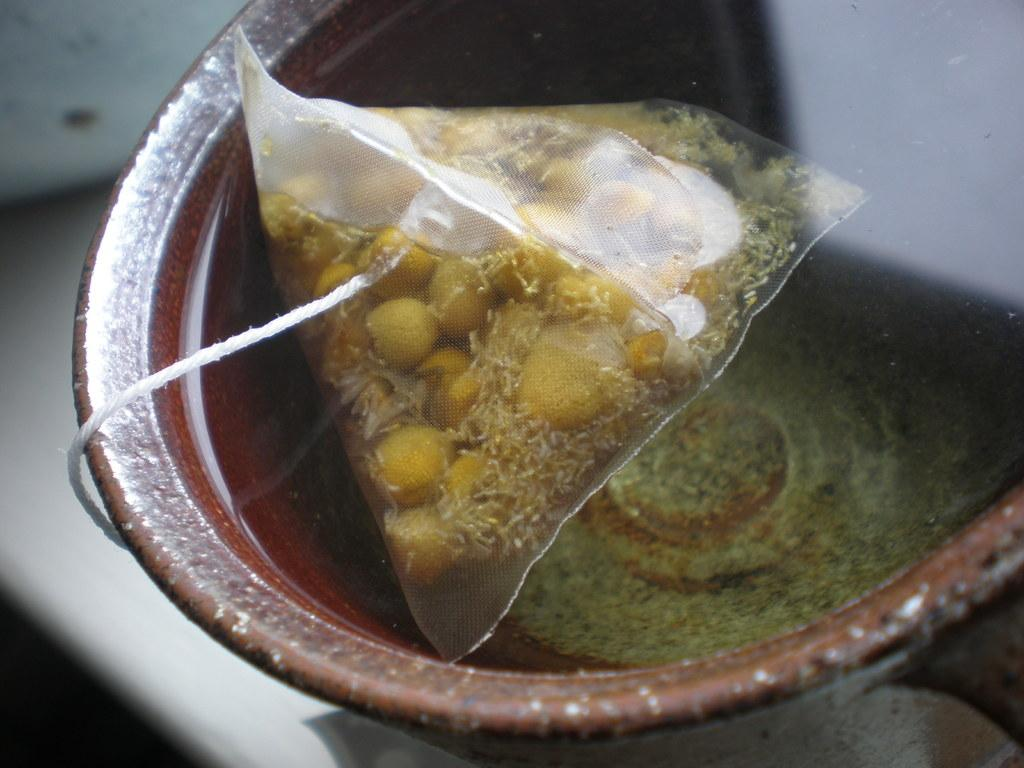What is visible in the image? Water is visible in the image. What object is present in the image that has a thread attached to it? There is a packet with a thread in the image. Where is the packet located? The packet is in a bowl. Can you describe the background of the image? The background of the image is blurred. What word is being spelled out by the ants in the image? There are no ants present in the image, and therefore no word being spelled out by them. What type of prose is being recited by the water in the image? There is no prose being recited by the water in the image; it is simply water visible in the image. 